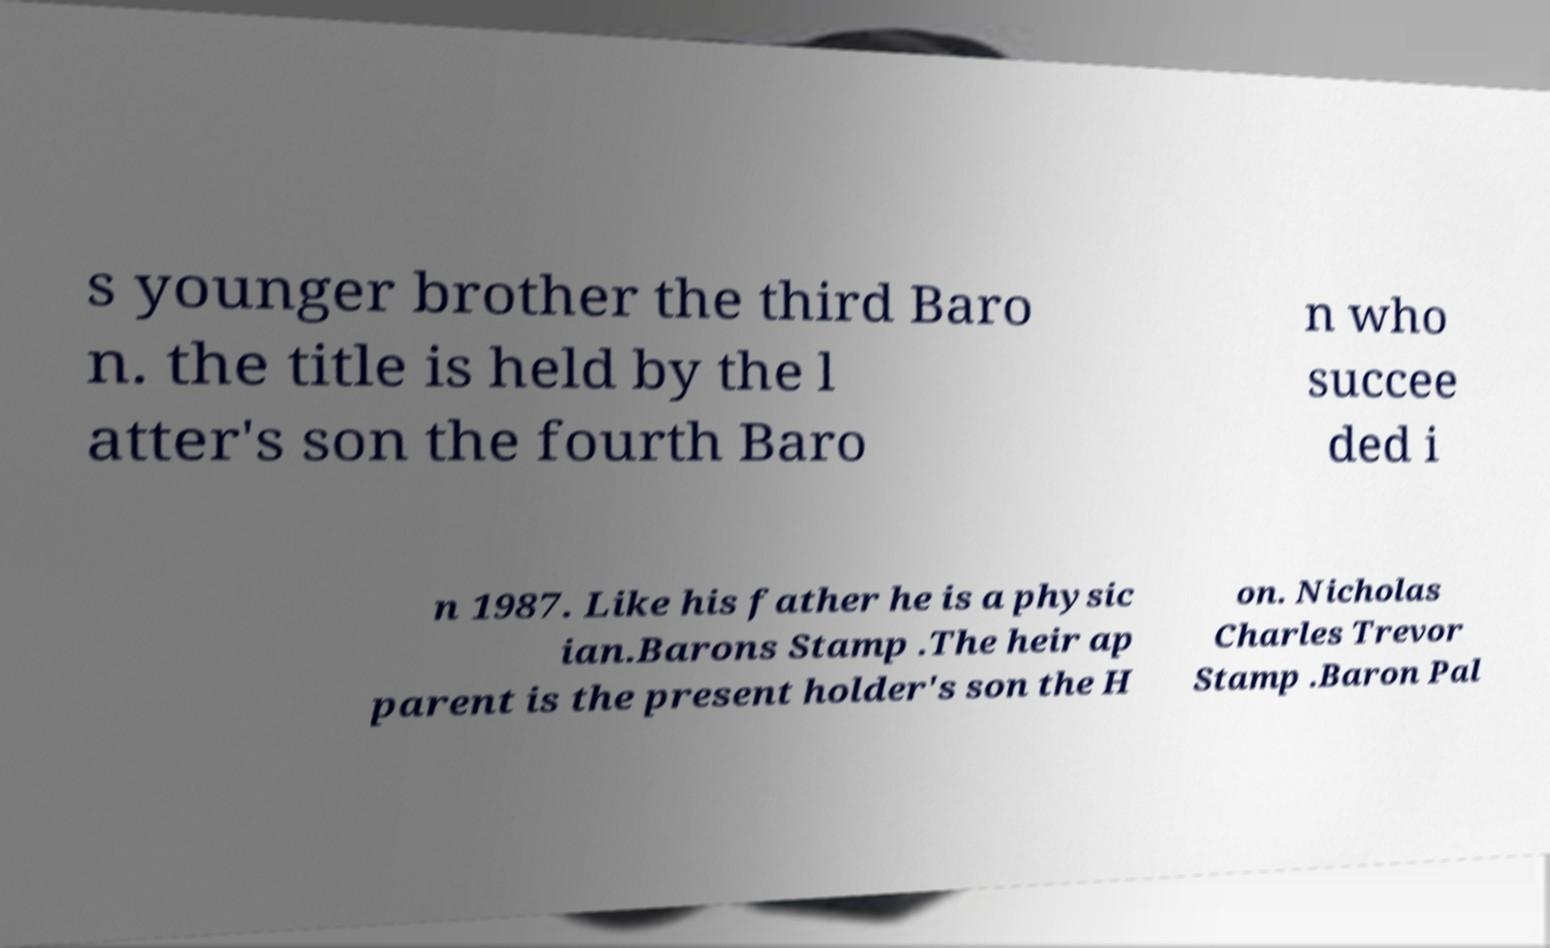There's text embedded in this image that I need extracted. Can you transcribe it verbatim? s younger brother the third Baro n. the title is held by the l atter's son the fourth Baro n who succee ded i n 1987. Like his father he is a physic ian.Barons Stamp .The heir ap parent is the present holder's son the H on. Nicholas Charles Trevor Stamp .Baron Pal 